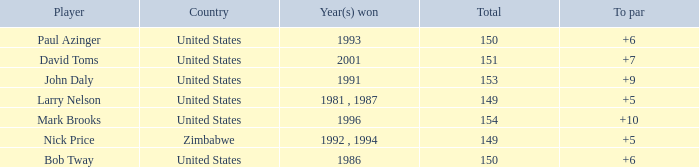What is Zimbabwe's total with a to par higher than 5? None. 